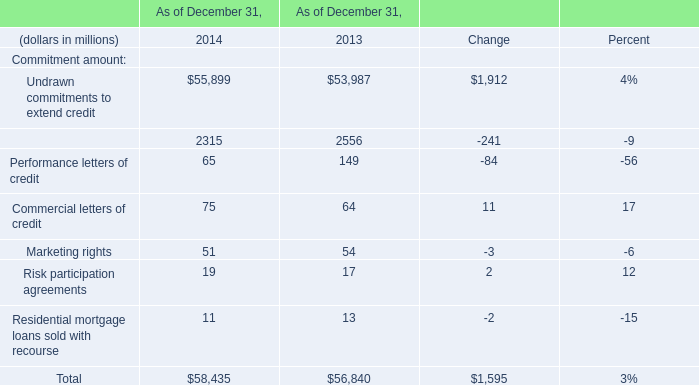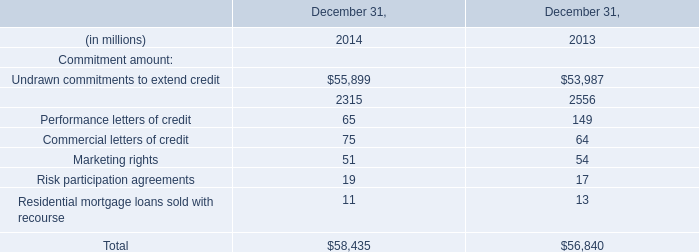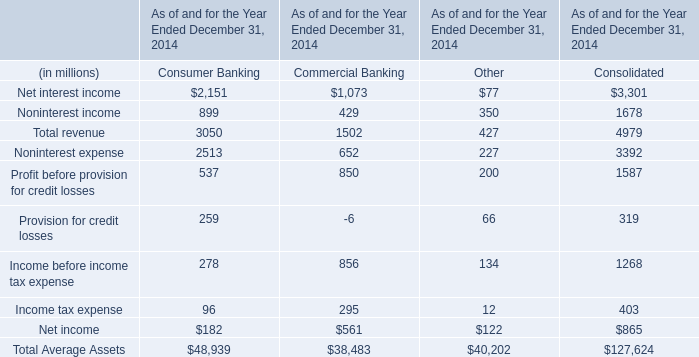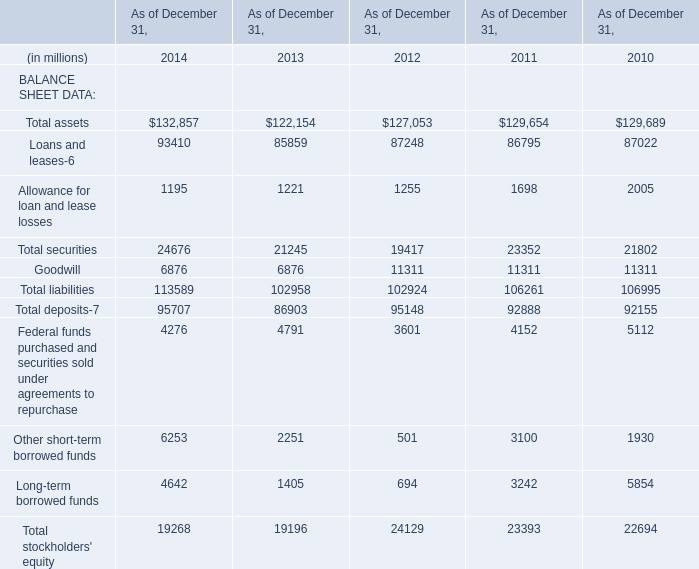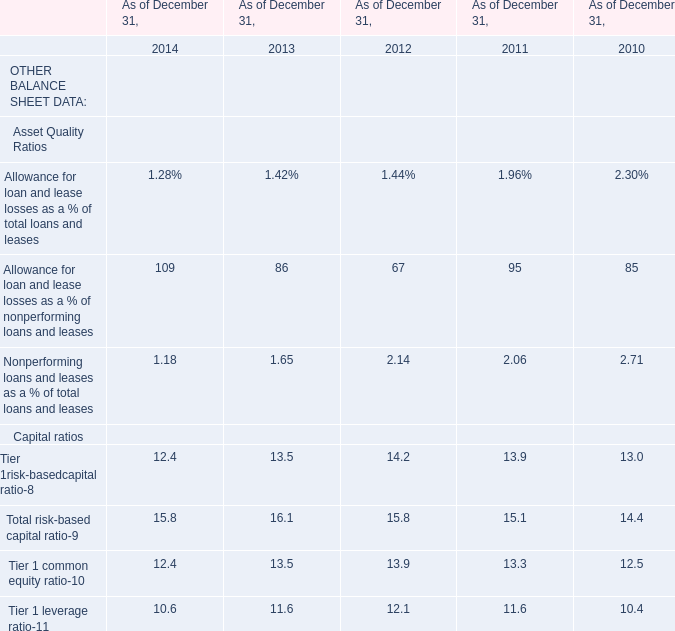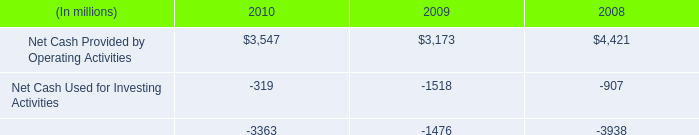What was the total amount of Total liabilities in 2013? (in million) 
Answer: 102958. 